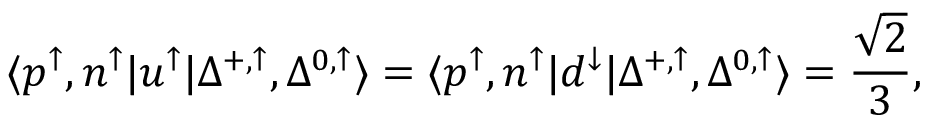Convert formula to latex. <formula><loc_0><loc_0><loc_500><loc_500>\langle p ^ { \uparrow } , n ^ { \uparrow } | u ^ { \uparrow } | \Delta ^ { + , \uparrow } , \Delta ^ { 0 , \uparrow } \rangle = \langle p ^ { \uparrow } , n ^ { \uparrow } | d ^ { \downarrow } | \Delta ^ { + , \uparrow } , \Delta ^ { 0 , \uparrow } \rangle = \frac { \sqrt { 2 } } { 3 } ,</formula> 